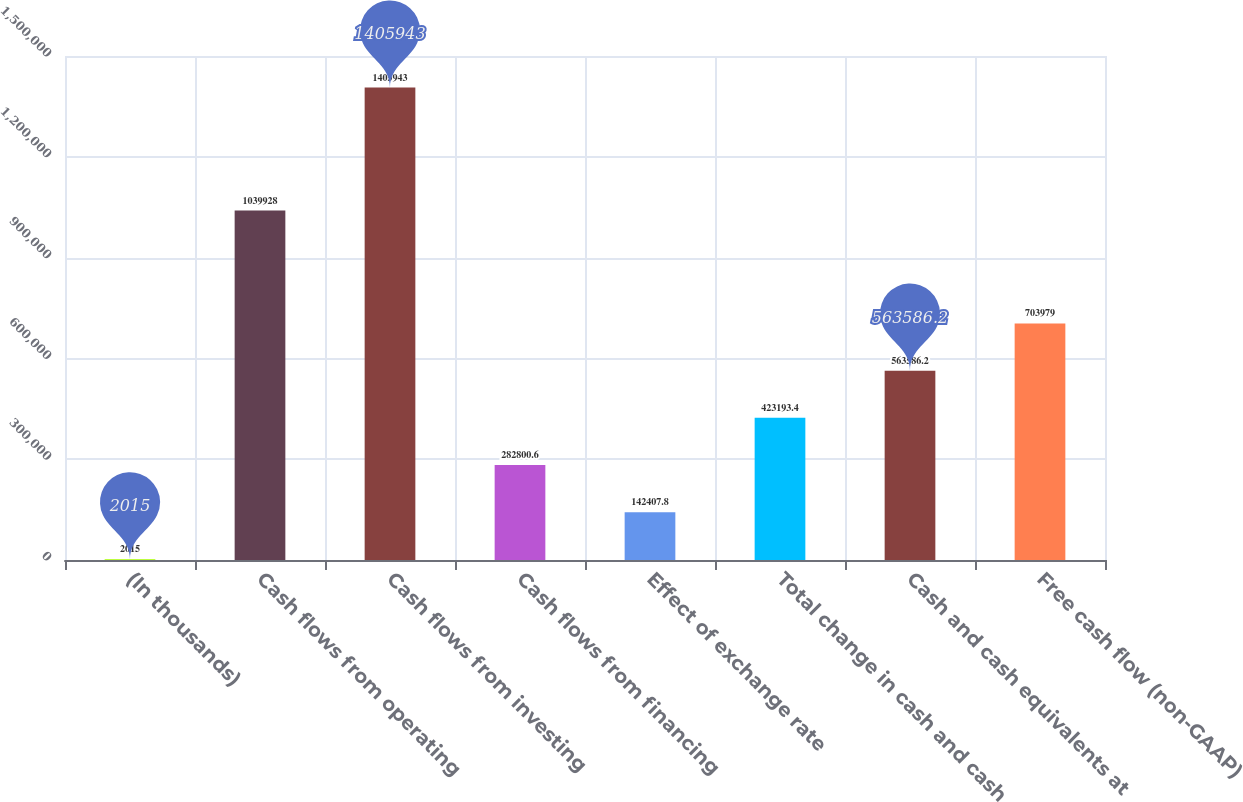<chart> <loc_0><loc_0><loc_500><loc_500><bar_chart><fcel>(In thousands)<fcel>Cash flows from operating<fcel>Cash flows from investing<fcel>Cash flows from financing<fcel>Effect of exchange rate<fcel>Total change in cash and cash<fcel>Cash and cash equivalents at<fcel>Free cash flow (non-GAAP)<nl><fcel>2015<fcel>1.03993e+06<fcel>1.40594e+06<fcel>282801<fcel>142408<fcel>423193<fcel>563586<fcel>703979<nl></chart> 